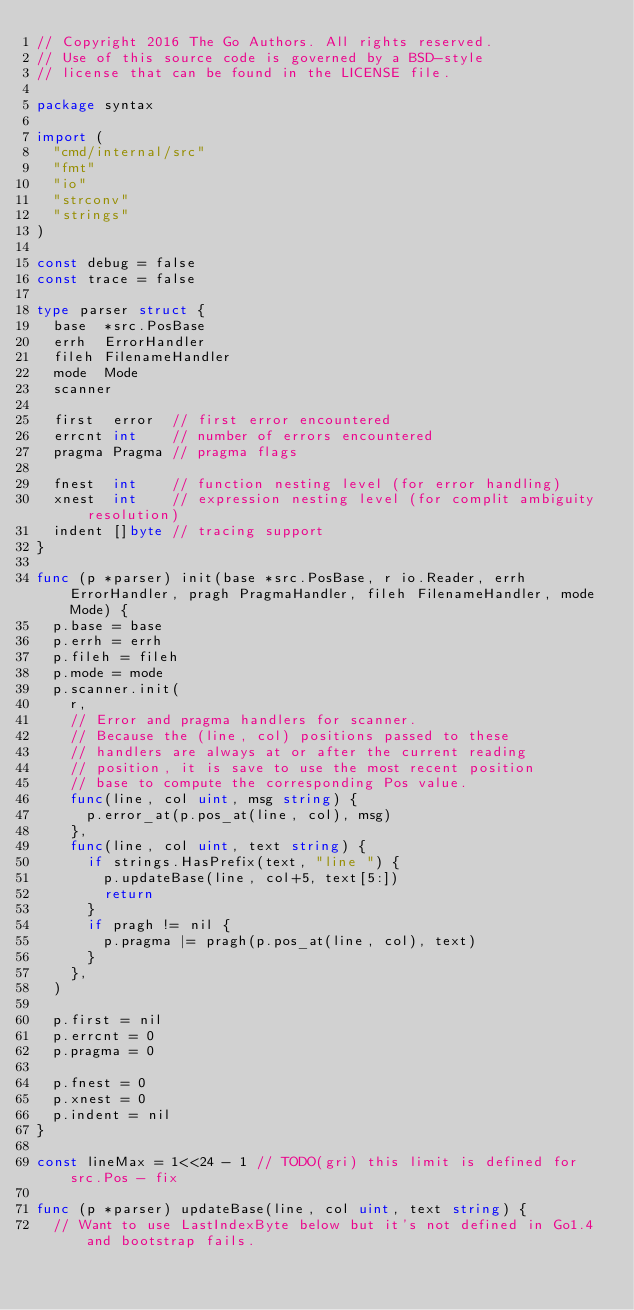Convert code to text. <code><loc_0><loc_0><loc_500><loc_500><_Go_>// Copyright 2016 The Go Authors. All rights reserved.
// Use of this source code is governed by a BSD-style
// license that can be found in the LICENSE file.

package syntax

import (
	"cmd/internal/src"
	"fmt"
	"io"
	"strconv"
	"strings"
)

const debug = false
const trace = false

type parser struct {
	base  *src.PosBase
	errh  ErrorHandler
	fileh FilenameHandler
	mode  Mode
	scanner

	first  error  // first error encountered
	errcnt int    // number of errors encountered
	pragma Pragma // pragma flags

	fnest  int    // function nesting level (for error handling)
	xnest  int    // expression nesting level (for complit ambiguity resolution)
	indent []byte // tracing support
}

func (p *parser) init(base *src.PosBase, r io.Reader, errh ErrorHandler, pragh PragmaHandler, fileh FilenameHandler, mode Mode) {
	p.base = base
	p.errh = errh
	p.fileh = fileh
	p.mode = mode
	p.scanner.init(
		r,
		// Error and pragma handlers for scanner.
		// Because the (line, col) positions passed to these
		// handlers are always at or after the current reading
		// position, it is save to use the most recent position
		// base to compute the corresponding Pos value.
		func(line, col uint, msg string) {
			p.error_at(p.pos_at(line, col), msg)
		},
		func(line, col uint, text string) {
			if strings.HasPrefix(text, "line ") {
				p.updateBase(line, col+5, text[5:])
				return
			}
			if pragh != nil {
				p.pragma |= pragh(p.pos_at(line, col), text)
			}
		},
	)

	p.first = nil
	p.errcnt = 0
	p.pragma = 0

	p.fnest = 0
	p.xnest = 0
	p.indent = nil
}

const lineMax = 1<<24 - 1 // TODO(gri) this limit is defined for src.Pos - fix

func (p *parser) updateBase(line, col uint, text string) {
	// Want to use LastIndexByte below but it's not defined in Go1.4 and bootstrap fails.</code> 